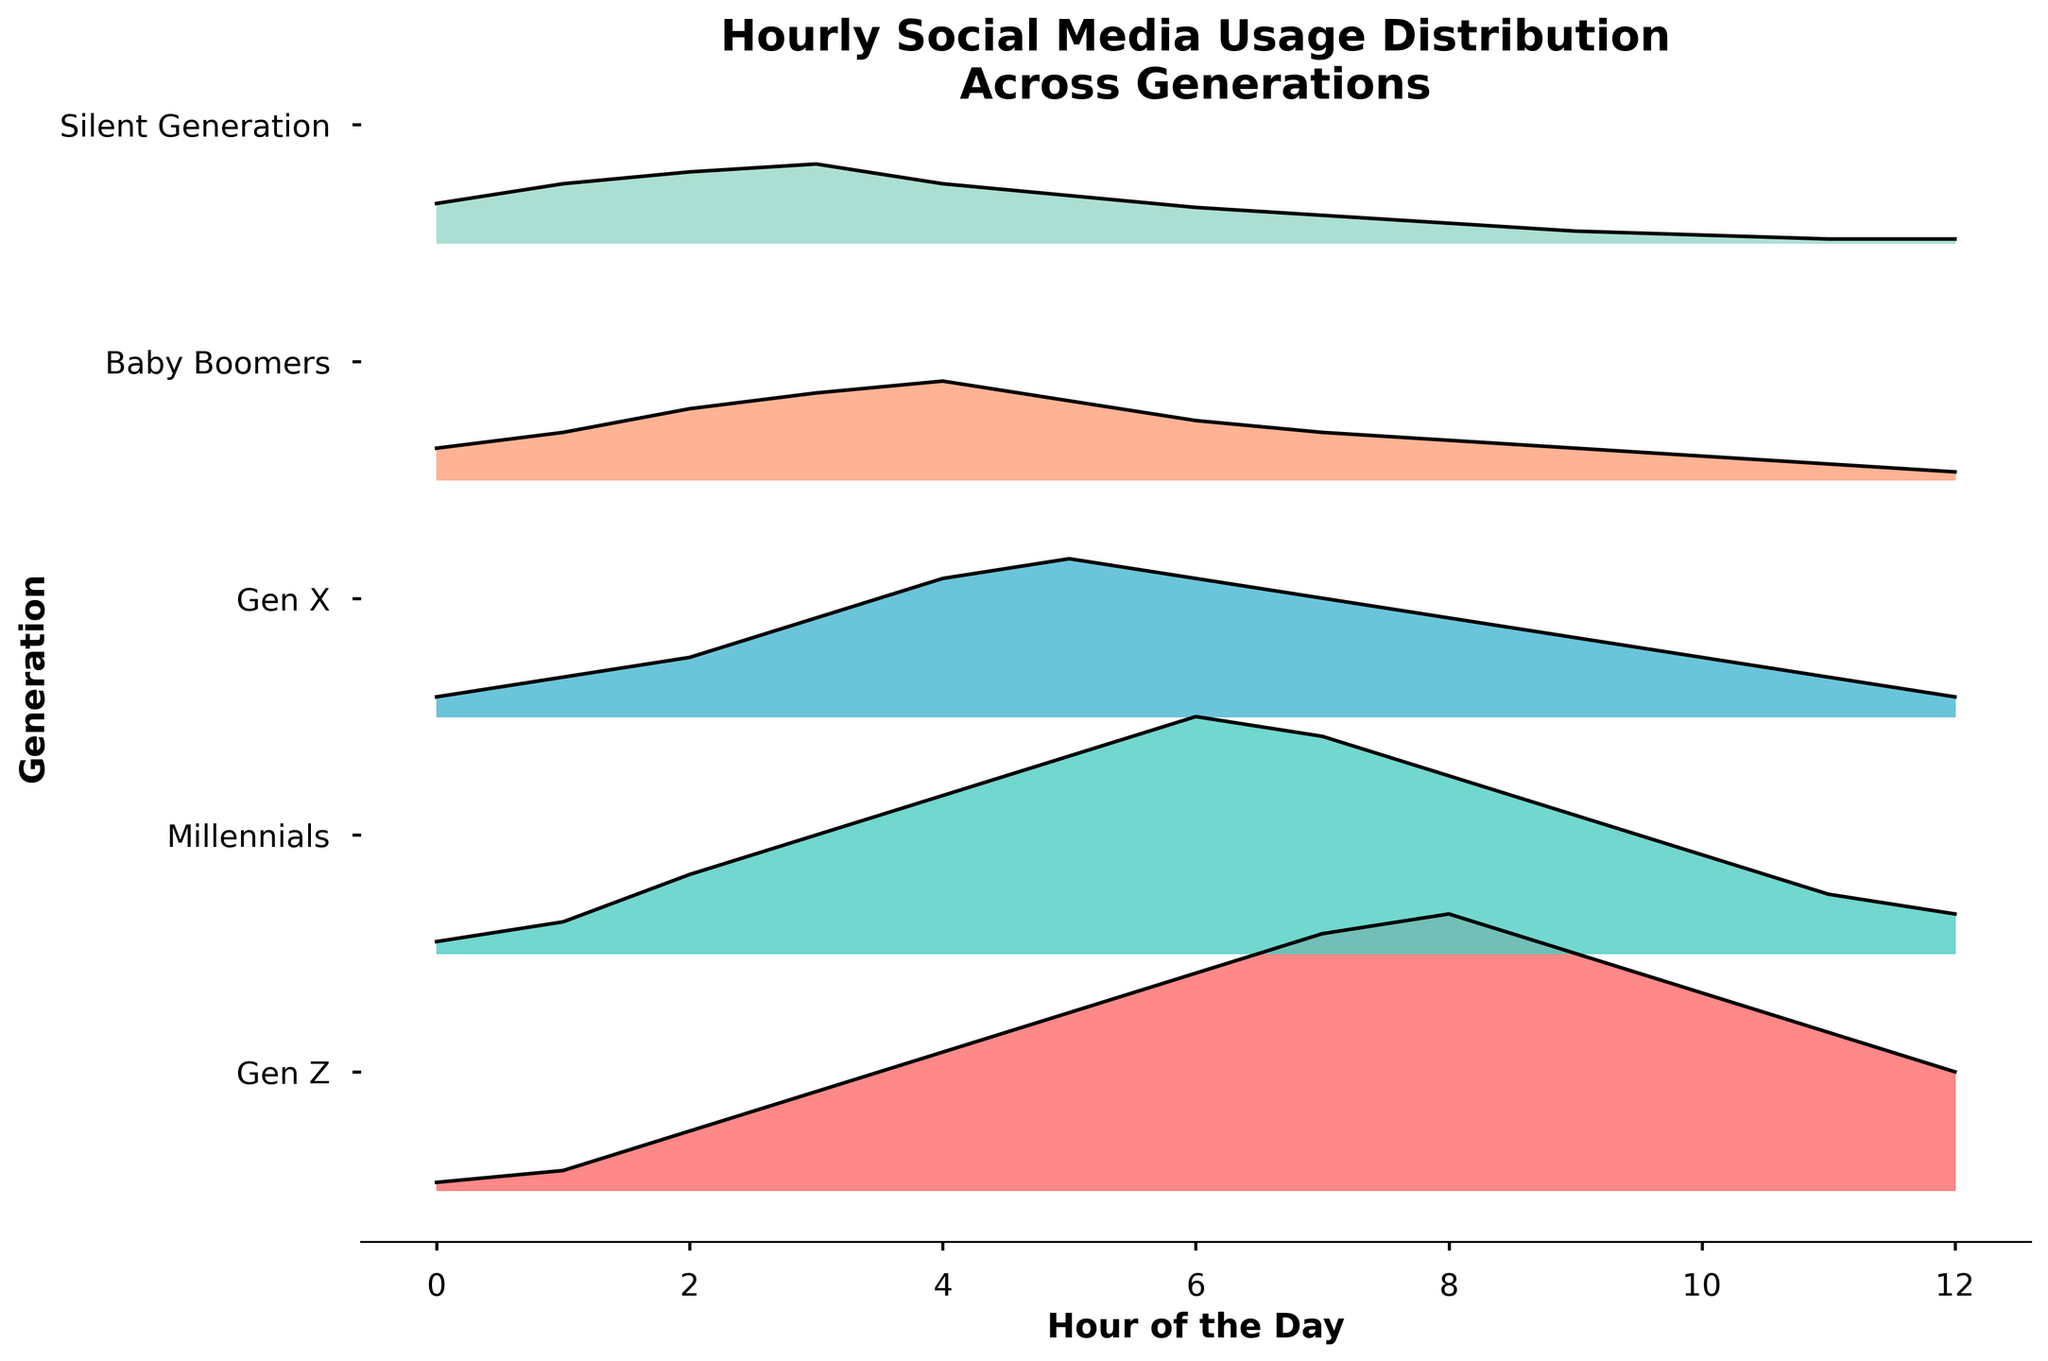What's the title of the figure? The title is displayed prominently at the top of the figure, clearly describing the content of the plot.
Answer: Hourly Social Media Usage Distribution Across Generations What are the axes labels on the figure? The x-axis label is seen at the bottom and the y-axis label is seen on the left side of the figure.
Answer: Hour of the Day (x-axis), Generation (y-axis) How many generations are represented in the plot? This can be counted by reviewing the y-axis labels, each corresponding to a different generation.
Answer: 5 generations Which generation shows the highest social media usage at 10 AM? By locating 10 AM on the x-axis and observing the y-values of the curves, we can find the generation with the highest peak.
Answer: Gen Z What color represents the Millennials' social media usage? The color associated with the curve labeled Millennials on the y-axis can be identified.
Answer: Greenish-blue During what hours does the Baby Boomers' social media usage show a peak? By following the curve for Baby Boomers, the hours when it reaches its highest points can be noted.
Answer: 3 AM to 4 AM Compare the social media usage between Gen X and Millennials at 4 PM. Which generation has a higher usage? Locate 4 PM on the x-axis and compare the y-values of the curves for Gen X and Millennials.
Answer: Millennials What's the difference in social media usage between Gen Z and the Silent Generation at 8 AM? Locate 8 AM on the x-axis and subtract the y-value for the Silent Generation from that for Gen Z.
Answer: 0.61 Which generation has the most consistent social media usage throughout the day? This can be determined by identifying the generation whose curve shows the least variation across hours.
Answer: Silent Generation What's the average social media usage for Gen X during the 12-hour period from midnight to noon? Sum the usage values for Gen X from midnight to noon and divide by 12 to get the average.
Answer: 0.27 